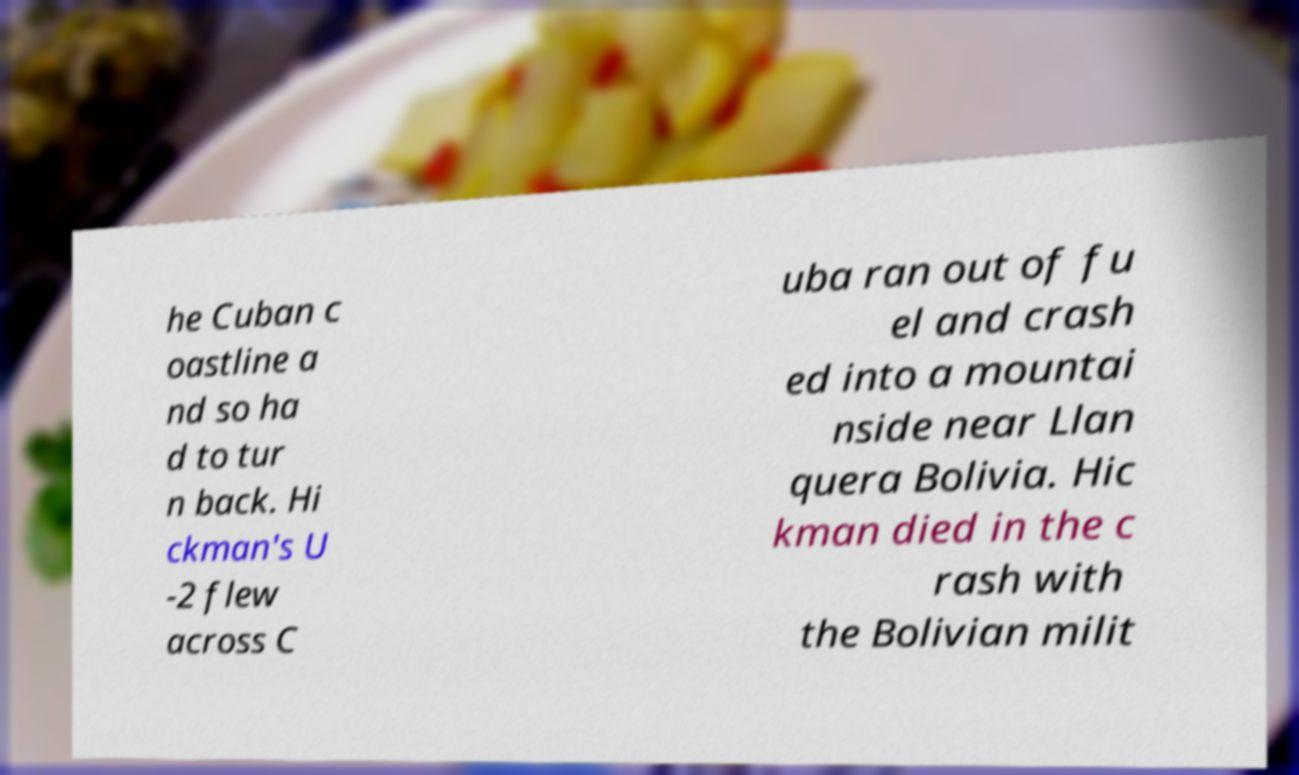For documentation purposes, I need the text within this image transcribed. Could you provide that? he Cuban c oastline a nd so ha d to tur n back. Hi ckman's U -2 flew across C uba ran out of fu el and crash ed into a mountai nside near Llan quera Bolivia. Hic kman died in the c rash with the Bolivian milit 